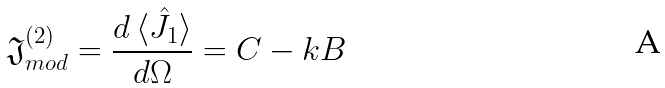<formula> <loc_0><loc_0><loc_500><loc_500>\mathfrak { J } ^ { ( 2 ) } _ { m o d } = \frac { d \, \langle \hat { J } _ { 1 } \rangle } { d \Omega } = C - k B \,</formula> 